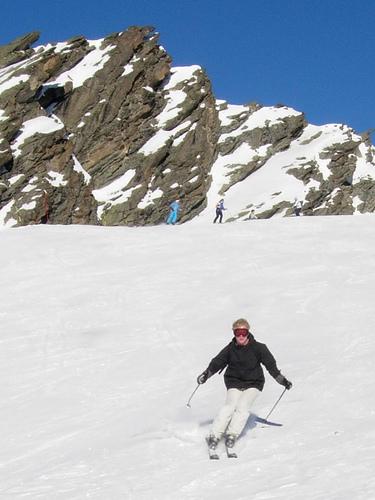How many people are at the top of the slope?
Answer briefly. 2. Is there water in the photo?
Be succinct. No. What is the lady in the foreground doing?
Short answer required. Skiing. 